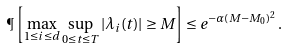<formula> <loc_0><loc_0><loc_500><loc_500>\P \left [ \max _ { 1 \leq i \leq d } \sup _ { 0 \leq t \leq T } | \lambda _ { i } ( t ) | \geq M \right ] \leq e ^ { - \alpha ( M - M _ { 0 } ) ^ { 2 } } \, .</formula> 